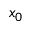<formula> <loc_0><loc_0><loc_500><loc_500>x _ { 0 }</formula> 